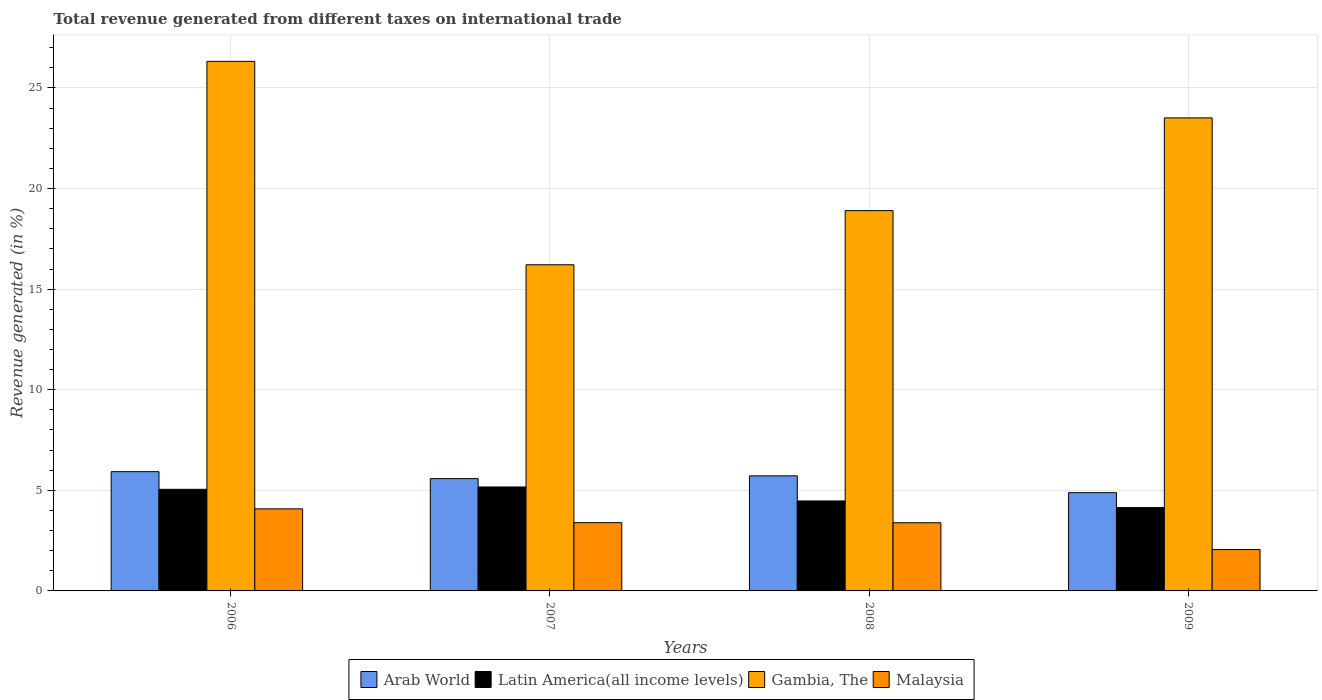How many different coloured bars are there?
Ensure brevity in your answer.  4. How many groups of bars are there?
Offer a terse response. 4. Are the number of bars on each tick of the X-axis equal?
Your response must be concise. Yes. How many bars are there on the 3rd tick from the left?
Keep it short and to the point. 4. In how many cases, is the number of bars for a given year not equal to the number of legend labels?
Keep it short and to the point. 0. What is the total revenue generated in Latin America(all income levels) in 2008?
Ensure brevity in your answer.  4.47. Across all years, what is the maximum total revenue generated in Arab World?
Keep it short and to the point. 5.93. Across all years, what is the minimum total revenue generated in Malaysia?
Offer a very short reply. 2.06. What is the total total revenue generated in Latin America(all income levels) in the graph?
Your response must be concise. 18.83. What is the difference between the total revenue generated in Malaysia in 2006 and that in 2008?
Keep it short and to the point. 0.69. What is the difference between the total revenue generated in Latin America(all income levels) in 2009 and the total revenue generated in Arab World in 2006?
Your response must be concise. -1.79. What is the average total revenue generated in Latin America(all income levels) per year?
Keep it short and to the point. 4.71. In the year 2009, what is the difference between the total revenue generated in Gambia, The and total revenue generated in Arab World?
Your response must be concise. 18.63. What is the ratio of the total revenue generated in Malaysia in 2007 to that in 2009?
Provide a short and direct response. 1.65. Is the total revenue generated in Malaysia in 2007 less than that in 2008?
Keep it short and to the point. No. Is the difference between the total revenue generated in Gambia, The in 2007 and 2008 greater than the difference between the total revenue generated in Arab World in 2007 and 2008?
Ensure brevity in your answer.  No. What is the difference between the highest and the second highest total revenue generated in Arab World?
Provide a succinct answer. 0.21. What is the difference between the highest and the lowest total revenue generated in Malaysia?
Offer a very short reply. 2.02. Is the sum of the total revenue generated in Gambia, The in 2008 and 2009 greater than the maximum total revenue generated in Latin America(all income levels) across all years?
Give a very brief answer. Yes. What does the 3rd bar from the left in 2008 represents?
Provide a short and direct response. Gambia, The. What does the 2nd bar from the right in 2008 represents?
Ensure brevity in your answer.  Gambia, The. Is it the case that in every year, the sum of the total revenue generated in Malaysia and total revenue generated in Gambia, The is greater than the total revenue generated in Arab World?
Provide a short and direct response. Yes. How many bars are there?
Ensure brevity in your answer.  16. How many legend labels are there?
Your answer should be compact. 4. What is the title of the graph?
Offer a very short reply. Total revenue generated from different taxes on international trade. What is the label or title of the X-axis?
Offer a terse response. Years. What is the label or title of the Y-axis?
Offer a very short reply. Revenue generated (in %). What is the Revenue generated (in %) of Arab World in 2006?
Your response must be concise. 5.93. What is the Revenue generated (in %) in Latin America(all income levels) in 2006?
Offer a very short reply. 5.05. What is the Revenue generated (in %) in Gambia, The in 2006?
Provide a succinct answer. 26.32. What is the Revenue generated (in %) of Malaysia in 2006?
Your answer should be compact. 4.08. What is the Revenue generated (in %) in Arab World in 2007?
Your answer should be compact. 5.58. What is the Revenue generated (in %) of Latin America(all income levels) in 2007?
Offer a terse response. 5.17. What is the Revenue generated (in %) of Gambia, The in 2007?
Make the answer very short. 16.21. What is the Revenue generated (in %) in Malaysia in 2007?
Give a very brief answer. 3.39. What is the Revenue generated (in %) in Arab World in 2008?
Your answer should be very brief. 5.72. What is the Revenue generated (in %) of Latin America(all income levels) in 2008?
Give a very brief answer. 4.47. What is the Revenue generated (in %) of Gambia, The in 2008?
Provide a succinct answer. 18.9. What is the Revenue generated (in %) in Malaysia in 2008?
Give a very brief answer. 3.39. What is the Revenue generated (in %) of Arab World in 2009?
Give a very brief answer. 4.88. What is the Revenue generated (in %) of Latin America(all income levels) in 2009?
Offer a terse response. 4.14. What is the Revenue generated (in %) of Gambia, The in 2009?
Give a very brief answer. 23.51. What is the Revenue generated (in %) in Malaysia in 2009?
Your answer should be very brief. 2.06. Across all years, what is the maximum Revenue generated (in %) of Arab World?
Your answer should be very brief. 5.93. Across all years, what is the maximum Revenue generated (in %) of Latin America(all income levels)?
Give a very brief answer. 5.17. Across all years, what is the maximum Revenue generated (in %) of Gambia, The?
Provide a short and direct response. 26.32. Across all years, what is the maximum Revenue generated (in %) in Malaysia?
Offer a very short reply. 4.08. Across all years, what is the minimum Revenue generated (in %) of Arab World?
Your response must be concise. 4.88. Across all years, what is the minimum Revenue generated (in %) in Latin America(all income levels)?
Offer a terse response. 4.14. Across all years, what is the minimum Revenue generated (in %) of Gambia, The?
Ensure brevity in your answer.  16.21. Across all years, what is the minimum Revenue generated (in %) in Malaysia?
Make the answer very short. 2.06. What is the total Revenue generated (in %) of Arab World in the graph?
Give a very brief answer. 22.11. What is the total Revenue generated (in %) in Latin America(all income levels) in the graph?
Keep it short and to the point. 18.83. What is the total Revenue generated (in %) of Gambia, The in the graph?
Give a very brief answer. 84.95. What is the total Revenue generated (in %) in Malaysia in the graph?
Keep it short and to the point. 12.92. What is the difference between the Revenue generated (in %) in Arab World in 2006 and that in 2007?
Your answer should be very brief. 0.35. What is the difference between the Revenue generated (in %) in Latin America(all income levels) in 2006 and that in 2007?
Ensure brevity in your answer.  -0.12. What is the difference between the Revenue generated (in %) in Gambia, The in 2006 and that in 2007?
Keep it short and to the point. 10.11. What is the difference between the Revenue generated (in %) of Malaysia in 2006 and that in 2007?
Offer a terse response. 0.69. What is the difference between the Revenue generated (in %) in Arab World in 2006 and that in 2008?
Ensure brevity in your answer.  0.21. What is the difference between the Revenue generated (in %) of Latin America(all income levels) in 2006 and that in 2008?
Ensure brevity in your answer.  0.58. What is the difference between the Revenue generated (in %) of Gambia, The in 2006 and that in 2008?
Offer a very short reply. 7.42. What is the difference between the Revenue generated (in %) in Malaysia in 2006 and that in 2008?
Offer a terse response. 0.69. What is the difference between the Revenue generated (in %) of Arab World in 2006 and that in 2009?
Provide a short and direct response. 1.04. What is the difference between the Revenue generated (in %) of Latin America(all income levels) in 2006 and that in 2009?
Give a very brief answer. 0.91. What is the difference between the Revenue generated (in %) of Gambia, The in 2006 and that in 2009?
Your answer should be very brief. 2.81. What is the difference between the Revenue generated (in %) in Malaysia in 2006 and that in 2009?
Provide a succinct answer. 2.02. What is the difference between the Revenue generated (in %) in Arab World in 2007 and that in 2008?
Offer a very short reply. -0.14. What is the difference between the Revenue generated (in %) in Latin America(all income levels) in 2007 and that in 2008?
Offer a very short reply. 0.69. What is the difference between the Revenue generated (in %) in Gambia, The in 2007 and that in 2008?
Keep it short and to the point. -2.69. What is the difference between the Revenue generated (in %) in Malaysia in 2007 and that in 2008?
Provide a succinct answer. 0.01. What is the difference between the Revenue generated (in %) of Arab World in 2007 and that in 2009?
Give a very brief answer. 0.7. What is the difference between the Revenue generated (in %) of Latin America(all income levels) in 2007 and that in 2009?
Provide a succinct answer. 1.02. What is the difference between the Revenue generated (in %) of Gambia, The in 2007 and that in 2009?
Provide a short and direct response. -7.3. What is the difference between the Revenue generated (in %) in Malaysia in 2007 and that in 2009?
Ensure brevity in your answer.  1.33. What is the difference between the Revenue generated (in %) in Arab World in 2008 and that in 2009?
Offer a very short reply. 0.84. What is the difference between the Revenue generated (in %) in Latin America(all income levels) in 2008 and that in 2009?
Ensure brevity in your answer.  0.33. What is the difference between the Revenue generated (in %) in Gambia, The in 2008 and that in 2009?
Provide a succinct answer. -4.61. What is the difference between the Revenue generated (in %) of Malaysia in 2008 and that in 2009?
Your response must be concise. 1.33. What is the difference between the Revenue generated (in %) in Arab World in 2006 and the Revenue generated (in %) in Latin America(all income levels) in 2007?
Provide a short and direct response. 0.76. What is the difference between the Revenue generated (in %) in Arab World in 2006 and the Revenue generated (in %) in Gambia, The in 2007?
Make the answer very short. -10.28. What is the difference between the Revenue generated (in %) of Arab World in 2006 and the Revenue generated (in %) of Malaysia in 2007?
Your answer should be compact. 2.53. What is the difference between the Revenue generated (in %) in Latin America(all income levels) in 2006 and the Revenue generated (in %) in Gambia, The in 2007?
Your answer should be very brief. -11.16. What is the difference between the Revenue generated (in %) in Latin America(all income levels) in 2006 and the Revenue generated (in %) in Malaysia in 2007?
Provide a short and direct response. 1.66. What is the difference between the Revenue generated (in %) in Gambia, The in 2006 and the Revenue generated (in %) in Malaysia in 2007?
Give a very brief answer. 22.93. What is the difference between the Revenue generated (in %) of Arab World in 2006 and the Revenue generated (in %) of Latin America(all income levels) in 2008?
Your response must be concise. 1.46. What is the difference between the Revenue generated (in %) in Arab World in 2006 and the Revenue generated (in %) in Gambia, The in 2008?
Offer a terse response. -12.98. What is the difference between the Revenue generated (in %) in Arab World in 2006 and the Revenue generated (in %) in Malaysia in 2008?
Offer a terse response. 2.54. What is the difference between the Revenue generated (in %) of Latin America(all income levels) in 2006 and the Revenue generated (in %) of Gambia, The in 2008?
Ensure brevity in your answer.  -13.85. What is the difference between the Revenue generated (in %) of Latin America(all income levels) in 2006 and the Revenue generated (in %) of Malaysia in 2008?
Your answer should be very brief. 1.66. What is the difference between the Revenue generated (in %) in Gambia, The in 2006 and the Revenue generated (in %) in Malaysia in 2008?
Provide a short and direct response. 22.93. What is the difference between the Revenue generated (in %) of Arab World in 2006 and the Revenue generated (in %) of Latin America(all income levels) in 2009?
Provide a short and direct response. 1.79. What is the difference between the Revenue generated (in %) of Arab World in 2006 and the Revenue generated (in %) of Gambia, The in 2009?
Ensure brevity in your answer.  -17.58. What is the difference between the Revenue generated (in %) in Arab World in 2006 and the Revenue generated (in %) in Malaysia in 2009?
Give a very brief answer. 3.87. What is the difference between the Revenue generated (in %) in Latin America(all income levels) in 2006 and the Revenue generated (in %) in Gambia, The in 2009?
Ensure brevity in your answer.  -18.46. What is the difference between the Revenue generated (in %) of Latin America(all income levels) in 2006 and the Revenue generated (in %) of Malaysia in 2009?
Ensure brevity in your answer.  2.99. What is the difference between the Revenue generated (in %) of Gambia, The in 2006 and the Revenue generated (in %) of Malaysia in 2009?
Keep it short and to the point. 24.26. What is the difference between the Revenue generated (in %) in Arab World in 2007 and the Revenue generated (in %) in Latin America(all income levels) in 2008?
Ensure brevity in your answer.  1.11. What is the difference between the Revenue generated (in %) in Arab World in 2007 and the Revenue generated (in %) in Gambia, The in 2008?
Provide a short and direct response. -13.32. What is the difference between the Revenue generated (in %) in Arab World in 2007 and the Revenue generated (in %) in Malaysia in 2008?
Your response must be concise. 2.19. What is the difference between the Revenue generated (in %) of Latin America(all income levels) in 2007 and the Revenue generated (in %) of Gambia, The in 2008?
Keep it short and to the point. -13.74. What is the difference between the Revenue generated (in %) in Latin America(all income levels) in 2007 and the Revenue generated (in %) in Malaysia in 2008?
Offer a very short reply. 1.78. What is the difference between the Revenue generated (in %) of Gambia, The in 2007 and the Revenue generated (in %) of Malaysia in 2008?
Your answer should be very brief. 12.82. What is the difference between the Revenue generated (in %) of Arab World in 2007 and the Revenue generated (in %) of Latin America(all income levels) in 2009?
Ensure brevity in your answer.  1.44. What is the difference between the Revenue generated (in %) of Arab World in 2007 and the Revenue generated (in %) of Gambia, The in 2009?
Your response must be concise. -17.93. What is the difference between the Revenue generated (in %) of Arab World in 2007 and the Revenue generated (in %) of Malaysia in 2009?
Give a very brief answer. 3.52. What is the difference between the Revenue generated (in %) of Latin America(all income levels) in 2007 and the Revenue generated (in %) of Gambia, The in 2009?
Provide a short and direct response. -18.34. What is the difference between the Revenue generated (in %) in Latin America(all income levels) in 2007 and the Revenue generated (in %) in Malaysia in 2009?
Offer a very short reply. 3.11. What is the difference between the Revenue generated (in %) in Gambia, The in 2007 and the Revenue generated (in %) in Malaysia in 2009?
Provide a short and direct response. 14.15. What is the difference between the Revenue generated (in %) of Arab World in 2008 and the Revenue generated (in %) of Latin America(all income levels) in 2009?
Ensure brevity in your answer.  1.58. What is the difference between the Revenue generated (in %) of Arab World in 2008 and the Revenue generated (in %) of Gambia, The in 2009?
Offer a terse response. -17.79. What is the difference between the Revenue generated (in %) of Arab World in 2008 and the Revenue generated (in %) of Malaysia in 2009?
Offer a terse response. 3.66. What is the difference between the Revenue generated (in %) of Latin America(all income levels) in 2008 and the Revenue generated (in %) of Gambia, The in 2009?
Keep it short and to the point. -19.04. What is the difference between the Revenue generated (in %) in Latin America(all income levels) in 2008 and the Revenue generated (in %) in Malaysia in 2009?
Your answer should be very brief. 2.41. What is the difference between the Revenue generated (in %) in Gambia, The in 2008 and the Revenue generated (in %) in Malaysia in 2009?
Provide a short and direct response. 16.84. What is the average Revenue generated (in %) of Arab World per year?
Make the answer very short. 5.53. What is the average Revenue generated (in %) of Latin America(all income levels) per year?
Ensure brevity in your answer.  4.71. What is the average Revenue generated (in %) of Gambia, The per year?
Offer a very short reply. 21.24. What is the average Revenue generated (in %) of Malaysia per year?
Ensure brevity in your answer.  3.23. In the year 2006, what is the difference between the Revenue generated (in %) of Arab World and Revenue generated (in %) of Latin America(all income levels)?
Provide a succinct answer. 0.88. In the year 2006, what is the difference between the Revenue generated (in %) of Arab World and Revenue generated (in %) of Gambia, The?
Give a very brief answer. -20.39. In the year 2006, what is the difference between the Revenue generated (in %) of Arab World and Revenue generated (in %) of Malaysia?
Keep it short and to the point. 1.85. In the year 2006, what is the difference between the Revenue generated (in %) in Latin America(all income levels) and Revenue generated (in %) in Gambia, The?
Your response must be concise. -21.27. In the year 2006, what is the difference between the Revenue generated (in %) in Latin America(all income levels) and Revenue generated (in %) in Malaysia?
Your answer should be very brief. 0.97. In the year 2006, what is the difference between the Revenue generated (in %) in Gambia, The and Revenue generated (in %) in Malaysia?
Offer a terse response. 22.24. In the year 2007, what is the difference between the Revenue generated (in %) of Arab World and Revenue generated (in %) of Latin America(all income levels)?
Ensure brevity in your answer.  0.42. In the year 2007, what is the difference between the Revenue generated (in %) in Arab World and Revenue generated (in %) in Gambia, The?
Offer a very short reply. -10.63. In the year 2007, what is the difference between the Revenue generated (in %) of Arab World and Revenue generated (in %) of Malaysia?
Keep it short and to the point. 2.19. In the year 2007, what is the difference between the Revenue generated (in %) of Latin America(all income levels) and Revenue generated (in %) of Gambia, The?
Provide a short and direct response. -11.04. In the year 2007, what is the difference between the Revenue generated (in %) of Latin America(all income levels) and Revenue generated (in %) of Malaysia?
Offer a very short reply. 1.77. In the year 2007, what is the difference between the Revenue generated (in %) in Gambia, The and Revenue generated (in %) in Malaysia?
Your response must be concise. 12.82. In the year 2008, what is the difference between the Revenue generated (in %) of Arab World and Revenue generated (in %) of Latin America(all income levels)?
Your response must be concise. 1.25. In the year 2008, what is the difference between the Revenue generated (in %) in Arab World and Revenue generated (in %) in Gambia, The?
Your answer should be very brief. -13.18. In the year 2008, what is the difference between the Revenue generated (in %) of Arab World and Revenue generated (in %) of Malaysia?
Provide a short and direct response. 2.33. In the year 2008, what is the difference between the Revenue generated (in %) of Latin America(all income levels) and Revenue generated (in %) of Gambia, The?
Ensure brevity in your answer.  -14.43. In the year 2008, what is the difference between the Revenue generated (in %) in Latin America(all income levels) and Revenue generated (in %) in Malaysia?
Your answer should be compact. 1.08. In the year 2008, what is the difference between the Revenue generated (in %) in Gambia, The and Revenue generated (in %) in Malaysia?
Ensure brevity in your answer.  15.51. In the year 2009, what is the difference between the Revenue generated (in %) of Arab World and Revenue generated (in %) of Latin America(all income levels)?
Make the answer very short. 0.74. In the year 2009, what is the difference between the Revenue generated (in %) in Arab World and Revenue generated (in %) in Gambia, The?
Ensure brevity in your answer.  -18.63. In the year 2009, what is the difference between the Revenue generated (in %) in Arab World and Revenue generated (in %) in Malaysia?
Your answer should be very brief. 2.82. In the year 2009, what is the difference between the Revenue generated (in %) of Latin America(all income levels) and Revenue generated (in %) of Gambia, The?
Ensure brevity in your answer.  -19.37. In the year 2009, what is the difference between the Revenue generated (in %) of Latin America(all income levels) and Revenue generated (in %) of Malaysia?
Your response must be concise. 2.08. In the year 2009, what is the difference between the Revenue generated (in %) in Gambia, The and Revenue generated (in %) in Malaysia?
Offer a terse response. 21.45. What is the ratio of the Revenue generated (in %) in Arab World in 2006 to that in 2007?
Your response must be concise. 1.06. What is the ratio of the Revenue generated (in %) in Latin America(all income levels) in 2006 to that in 2007?
Make the answer very short. 0.98. What is the ratio of the Revenue generated (in %) of Gambia, The in 2006 to that in 2007?
Your answer should be very brief. 1.62. What is the ratio of the Revenue generated (in %) of Malaysia in 2006 to that in 2007?
Offer a very short reply. 1.2. What is the ratio of the Revenue generated (in %) of Arab World in 2006 to that in 2008?
Provide a succinct answer. 1.04. What is the ratio of the Revenue generated (in %) of Latin America(all income levels) in 2006 to that in 2008?
Offer a very short reply. 1.13. What is the ratio of the Revenue generated (in %) of Gambia, The in 2006 to that in 2008?
Keep it short and to the point. 1.39. What is the ratio of the Revenue generated (in %) of Malaysia in 2006 to that in 2008?
Offer a terse response. 1.2. What is the ratio of the Revenue generated (in %) of Arab World in 2006 to that in 2009?
Offer a very short reply. 1.21. What is the ratio of the Revenue generated (in %) of Latin America(all income levels) in 2006 to that in 2009?
Give a very brief answer. 1.22. What is the ratio of the Revenue generated (in %) of Gambia, The in 2006 to that in 2009?
Your answer should be compact. 1.12. What is the ratio of the Revenue generated (in %) of Malaysia in 2006 to that in 2009?
Ensure brevity in your answer.  1.98. What is the ratio of the Revenue generated (in %) of Arab World in 2007 to that in 2008?
Provide a short and direct response. 0.98. What is the ratio of the Revenue generated (in %) of Latin America(all income levels) in 2007 to that in 2008?
Ensure brevity in your answer.  1.16. What is the ratio of the Revenue generated (in %) of Gambia, The in 2007 to that in 2008?
Make the answer very short. 0.86. What is the ratio of the Revenue generated (in %) of Malaysia in 2007 to that in 2008?
Your response must be concise. 1. What is the ratio of the Revenue generated (in %) in Arab World in 2007 to that in 2009?
Offer a terse response. 1.14. What is the ratio of the Revenue generated (in %) of Latin America(all income levels) in 2007 to that in 2009?
Ensure brevity in your answer.  1.25. What is the ratio of the Revenue generated (in %) of Gambia, The in 2007 to that in 2009?
Your answer should be compact. 0.69. What is the ratio of the Revenue generated (in %) of Malaysia in 2007 to that in 2009?
Provide a succinct answer. 1.65. What is the ratio of the Revenue generated (in %) of Arab World in 2008 to that in 2009?
Give a very brief answer. 1.17. What is the ratio of the Revenue generated (in %) in Latin America(all income levels) in 2008 to that in 2009?
Ensure brevity in your answer.  1.08. What is the ratio of the Revenue generated (in %) in Gambia, The in 2008 to that in 2009?
Give a very brief answer. 0.8. What is the ratio of the Revenue generated (in %) in Malaysia in 2008 to that in 2009?
Ensure brevity in your answer.  1.65. What is the difference between the highest and the second highest Revenue generated (in %) of Arab World?
Ensure brevity in your answer.  0.21. What is the difference between the highest and the second highest Revenue generated (in %) in Latin America(all income levels)?
Your answer should be very brief. 0.12. What is the difference between the highest and the second highest Revenue generated (in %) in Gambia, The?
Your answer should be very brief. 2.81. What is the difference between the highest and the second highest Revenue generated (in %) in Malaysia?
Provide a succinct answer. 0.69. What is the difference between the highest and the lowest Revenue generated (in %) in Arab World?
Provide a short and direct response. 1.04. What is the difference between the highest and the lowest Revenue generated (in %) in Latin America(all income levels)?
Offer a terse response. 1.02. What is the difference between the highest and the lowest Revenue generated (in %) in Gambia, The?
Give a very brief answer. 10.11. What is the difference between the highest and the lowest Revenue generated (in %) of Malaysia?
Keep it short and to the point. 2.02. 